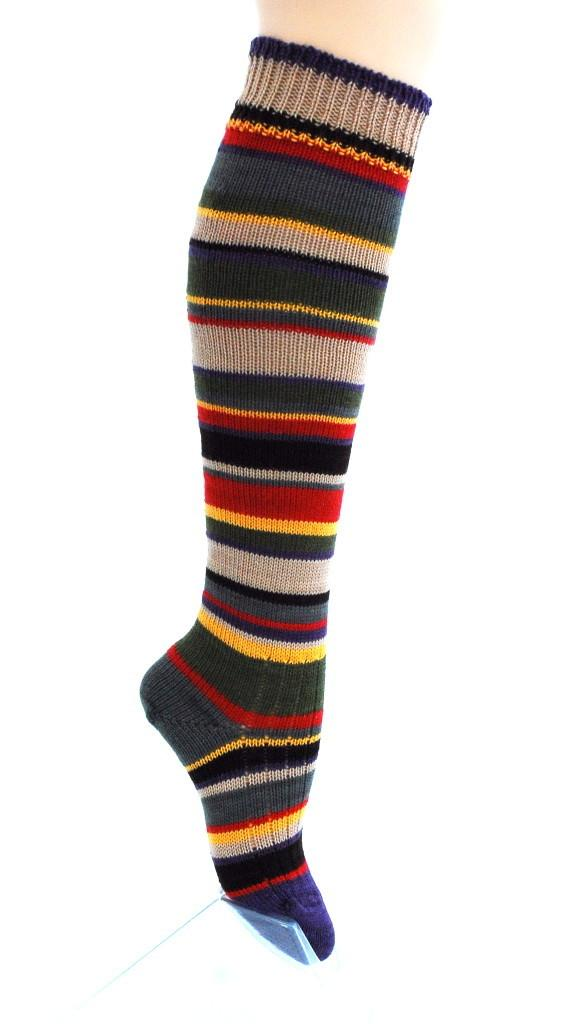What part of the human body is visible in the image? There is a human leg with socks in the image. What type of object can be seen at the bottom of the image? There is a glass object at the bottom of the image. How many volleyballs are visible in the image? There are no volleyballs present in the image. Is there a pocket on the human leg in the image? There is no pocket visible on the human leg in the image. 